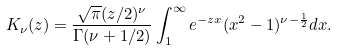Convert formula to latex. <formula><loc_0><loc_0><loc_500><loc_500>K _ { \nu } ( z ) = \frac { \sqrt { \pi } ( z / 2 ) ^ { \nu } } { \Gamma ( \nu + 1 / 2 ) } \int ^ { \infty } _ { 1 } e ^ { - z x } ( x ^ { 2 } - 1 ) ^ { \nu - \frac { 1 } { 2 } } d x .</formula> 